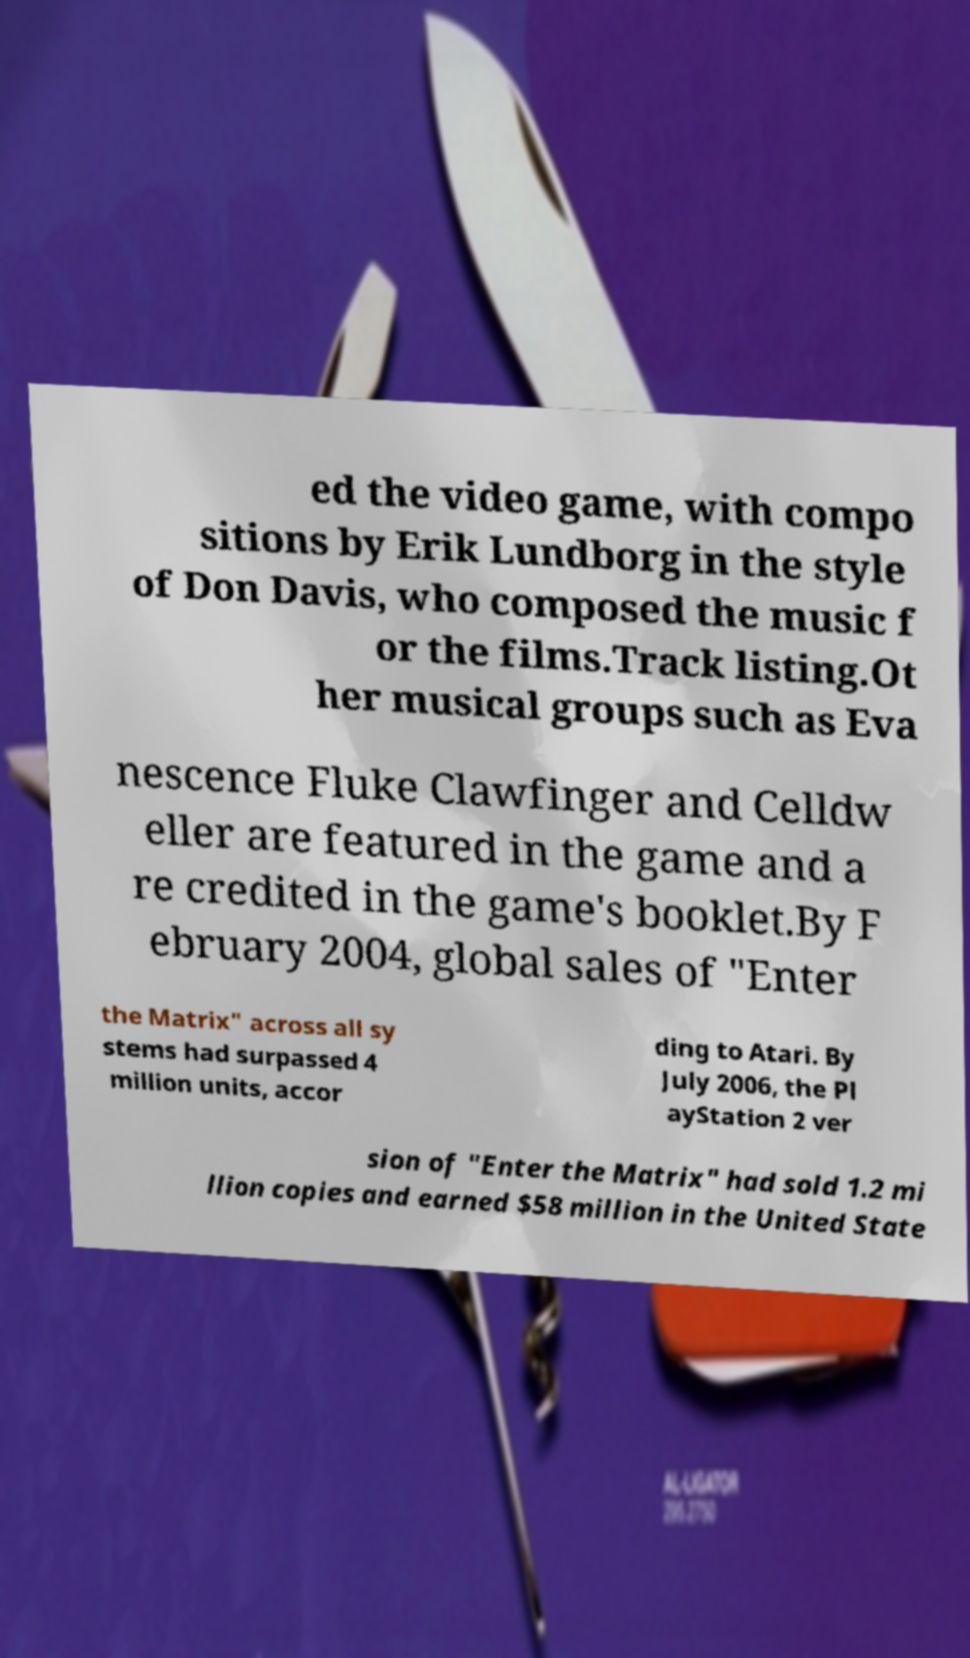Please identify and transcribe the text found in this image. ed the video game, with compo sitions by Erik Lundborg in the style of Don Davis, who composed the music f or the films.Track listing.Ot her musical groups such as Eva nescence Fluke Clawfinger and Celldw eller are featured in the game and a re credited in the game's booklet.By F ebruary 2004, global sales of "Enter the Matrix" across all sy stems had surpassed 4 million units, accor ding to Atari. By July 2006, the Pl ayStation 2 ver sion of "Enter the Matrix" had sold 1.2 mi llion copies and earned $58 million in the United State 